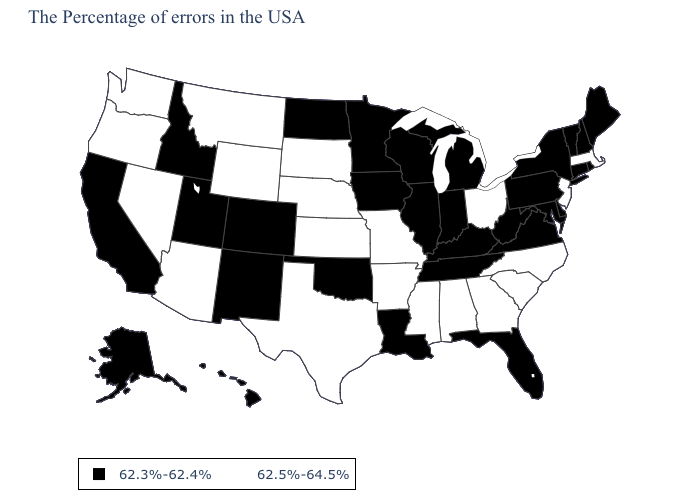What is the value of North Carolina?
Short answer required. 62.5%-64.5%. What is the value of Iowa?
Concise answer only. 62.3%-62.4%. What is the lowest value in states that border Rhode Island?
Be succinct. 62.3%-62.4%. What is the value of California?
Quick response, please. 62.3%-62.4%. What is the highest value in states that border Kentucky?
Give a very brief answer. 62.5%-64.5%. Name the states that have a value in the range 62.5%-64.5%?
Be succinct. Massachusetts, New Jersey, North Carolina, South Carolina, Ohio, Georgia, Alabama, Mississippi, Missouri, Arkansas, Kansas, Nebraska, Texas, South Dakota, Wyoming, Montana, Arizona, Nevada, Washington, Oregon. What is the value of Montana?
Quick response, please. 62.5%-64.5%. Name the states that have a value in the range 62.5%-64.5%?
Keep it brief. Massachusetts, New Jersey, North Carolina, South Carolina, Ohio, Georgia, Alabama, Mississippi, Missouri, Arkansas, Kansas, Nebraska, Texas, South Dakota, Wyoming, Montana, Arizona, Nevada, Washington, Oregon. Among the states that border Missouri , does Iowa have the lowest value?
Give a very brief answer. Yes. What is the highest value in the USA?
Give a very brief answer. 62.5%-64.5%. Among the states that border New York , does Massachusetts have the highest value?
Answer briefly. Yes. What is the value of New Mexico?
Quick response, please. 62.3%-62.4%. What is the highest value in states that border South Carolina?
Be succinct. 62.5%-64.5%. Name the states that have a value in the range 62.3%-62.4%?
Write a very short answer. Maine, Rhode Island, New Hampshire, Vermont, Connecticut, New York, Delaware, Maryland, Pennsylvania, Virginia, West Virginia, Florida, Michigan, Kentucky, Indiana, Tennessee, Wisconsin, Illinois, Louisiana, Minnesota, Iowa, Oklahoma, North Dakota, Colorado, New Mexico, Utah, Idaho, California, Alaska, Hawaii. What is the value of Nebraska?
Quick response, please. 62.5%-64.5%. 